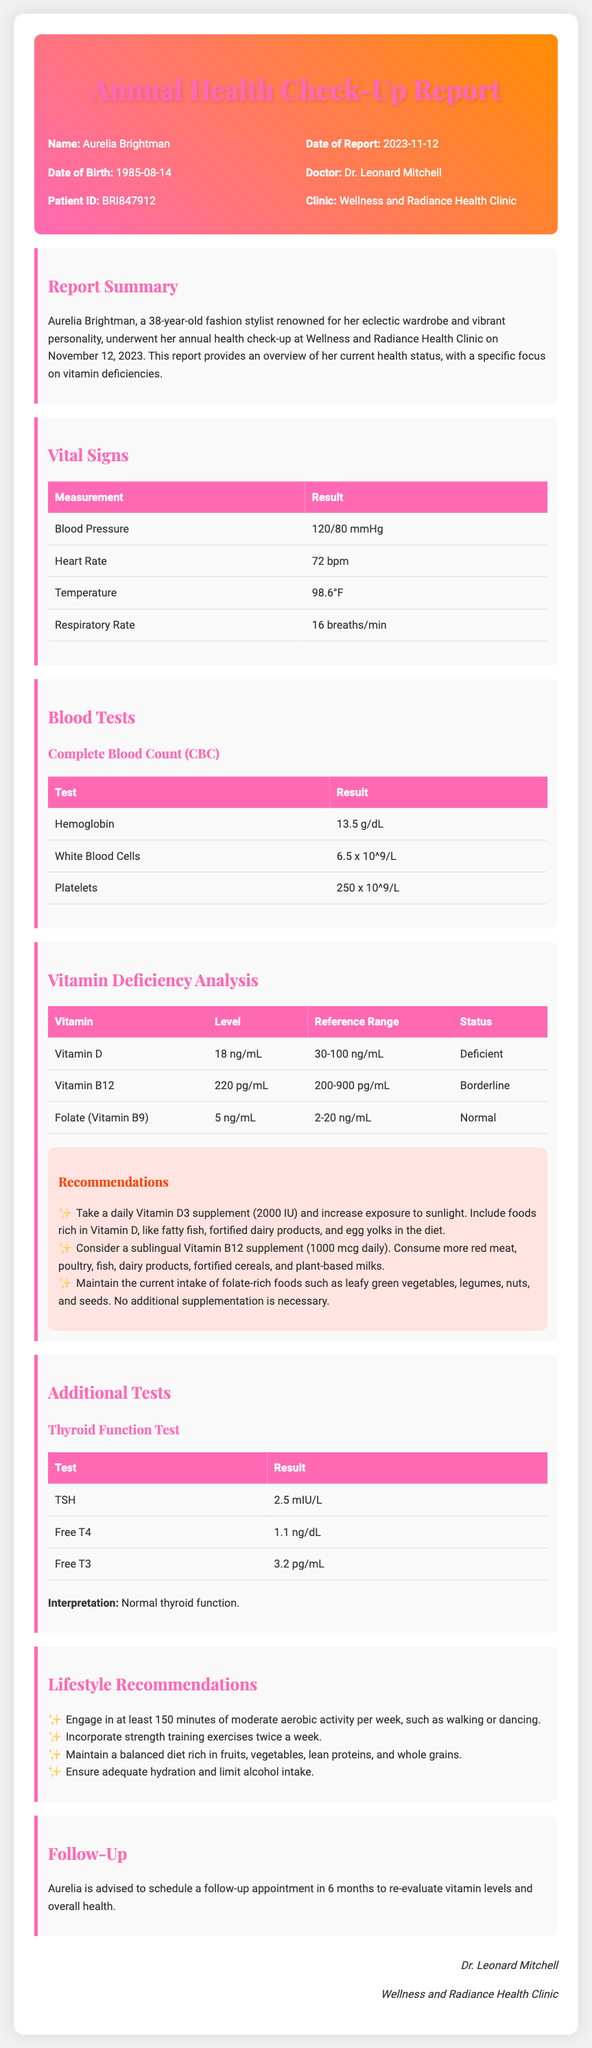What is the name of the patient? The name of the patient is specified in the document as Aurelia Brightman.
Answer: Aurelia Brightman What is the date of the report? The date of the report is explicitly mentioned as November 12, 2023.
Answer: 2023-11-12 What is Aurelia's Vitamin D level? The document lists Aurelia's Vitamin D level as 18 ng/mL.
Answer: 18 ng/mL What is recommended for Vitamin B12? The recommendations suggest considering a sublingual Vitamin B12 supplement (1000 mcg daily).
Answer: Sublingual Vitamin B12 supplement (1000 mcg daily) What is the result of the TSH test? The document states the result of the TSH test as 2.5 mIU/L.
Answer: 2.5 mIU/L What is the current status of Aurelia's Vitamin B12? The document indicates that the status of Vitamin B12 is borderline.
Answer: Borderline How often should Aurelia engage in aerobic activity? The document recommends engaging in at least 150 minutes of moderate aerobic activity per week.
Answer: 150 minutes per week What type of clinic conducted the check-up? The check-up was conducted at Wellness and Radiance Health Clinic.
Answer: Wellness and Radiance Health Clinic When should Aurelia schedule a follow-up appointment? The document advises scheduling a follow-up appointment in 6 months.
Answer: In 6 months 